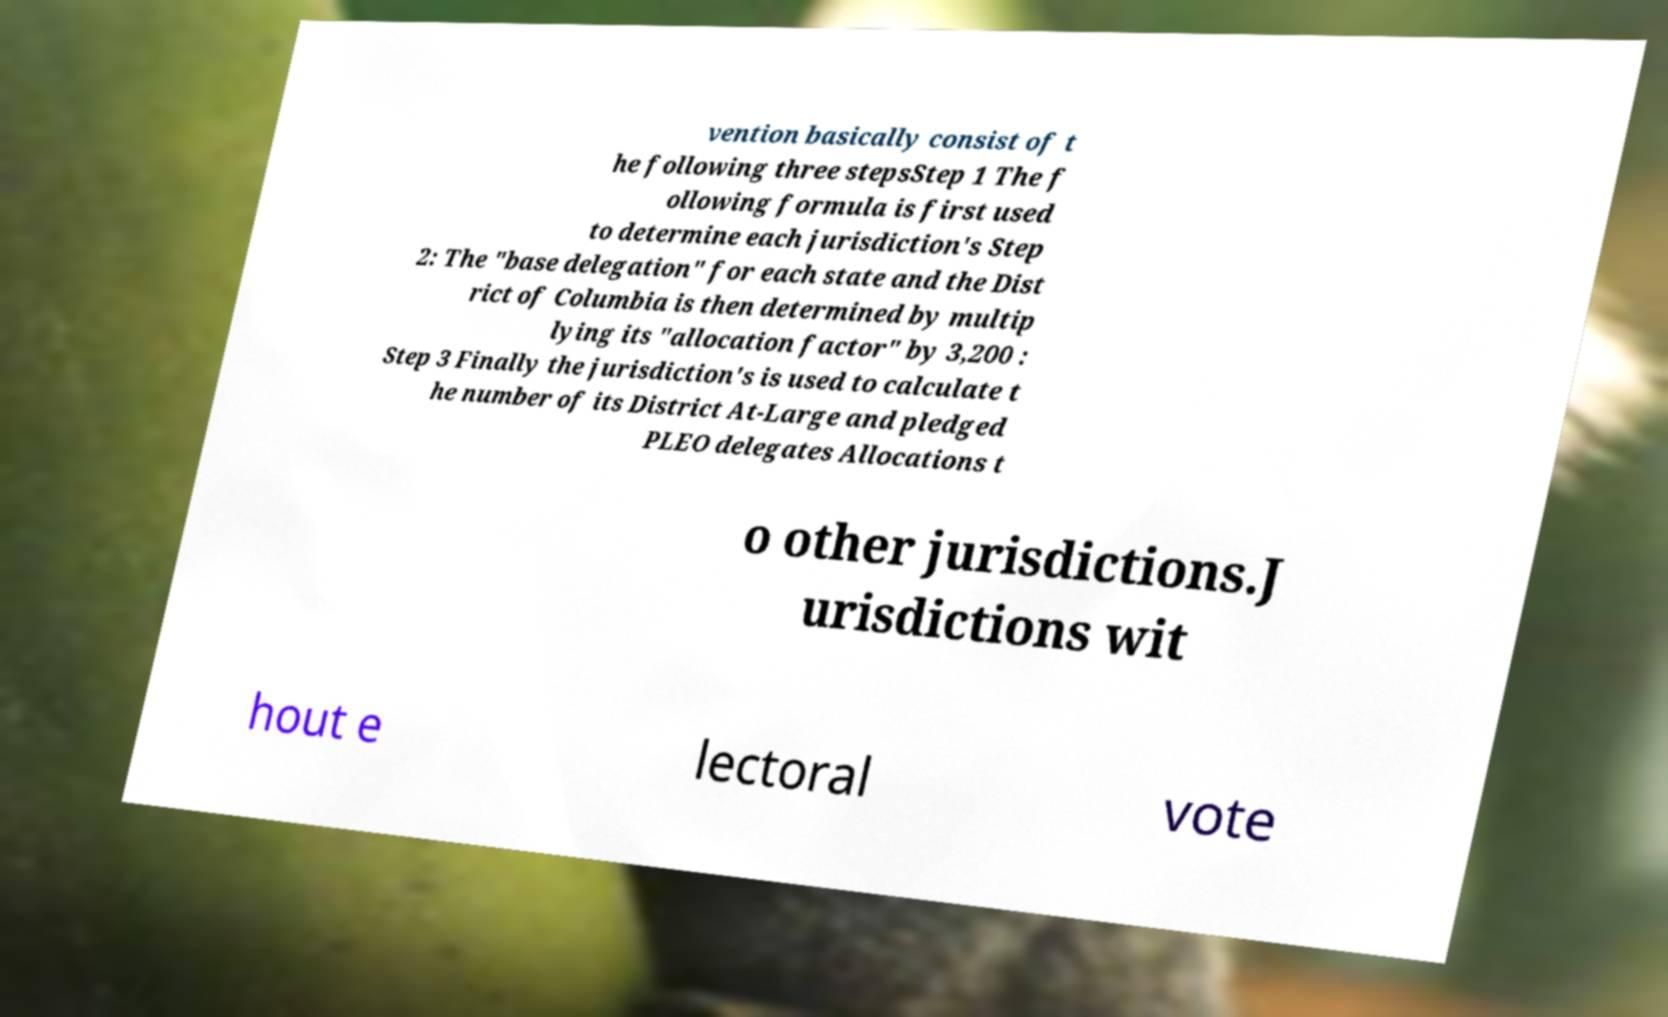Please read and relay the text visible in this image. What does it say? vention basically consist of t he following three stepsStep 1 The f ollowing formula is first used to determine each jurisdiction's Step 2: The "base delegation" for each state and the Dist rict of Columbia is then determined by multip lying its "allocation factor" by 3,200 : Step 3 Finally the jurisdiction's is used to calculate t he number of its District At-Large and pledged PLEO delegates Allocations t o other jurisdictions.J urisdictions wit hout e lectoral vote 